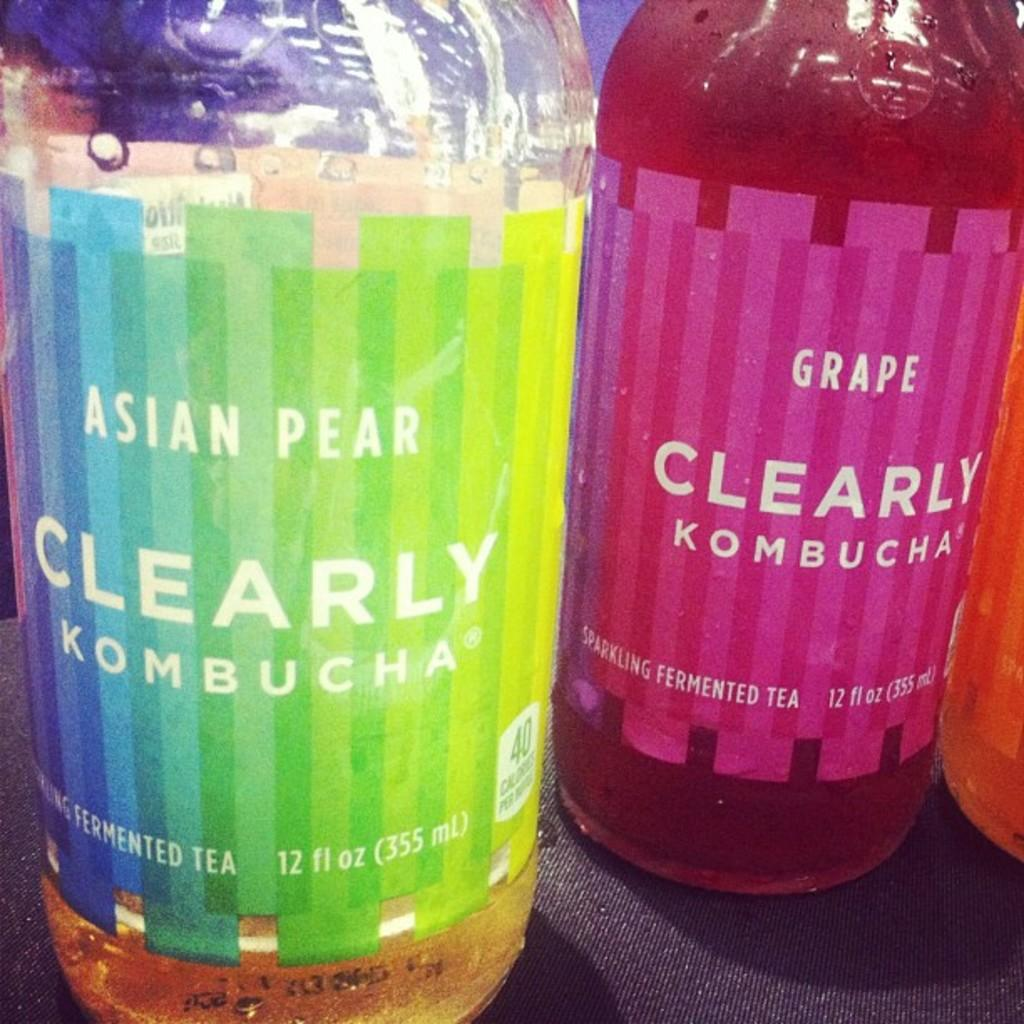<image>
Present a compact description of the photo's key features. Two bottles of Clearly Kombucha in Asian Pear and Grape. 